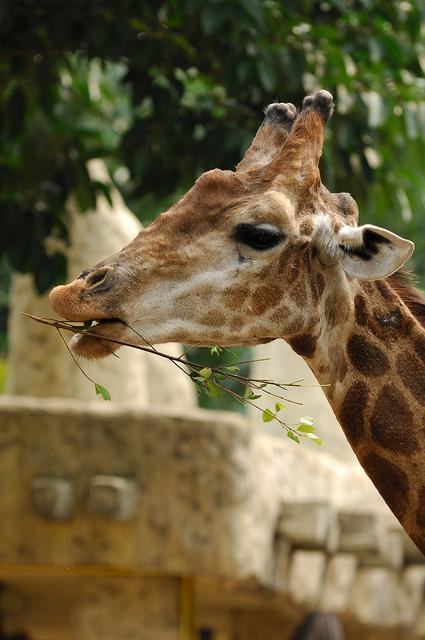What is the giraffe doing?
Answer briefly. Eating. What kind of animal is this?
Be succinct. Giraffe. How many giraffes are there?
Keep it brief. 1. What is in the background?
Be succinct. Trees. Which side is the giraffe facing?
Quick response, please. Left. 